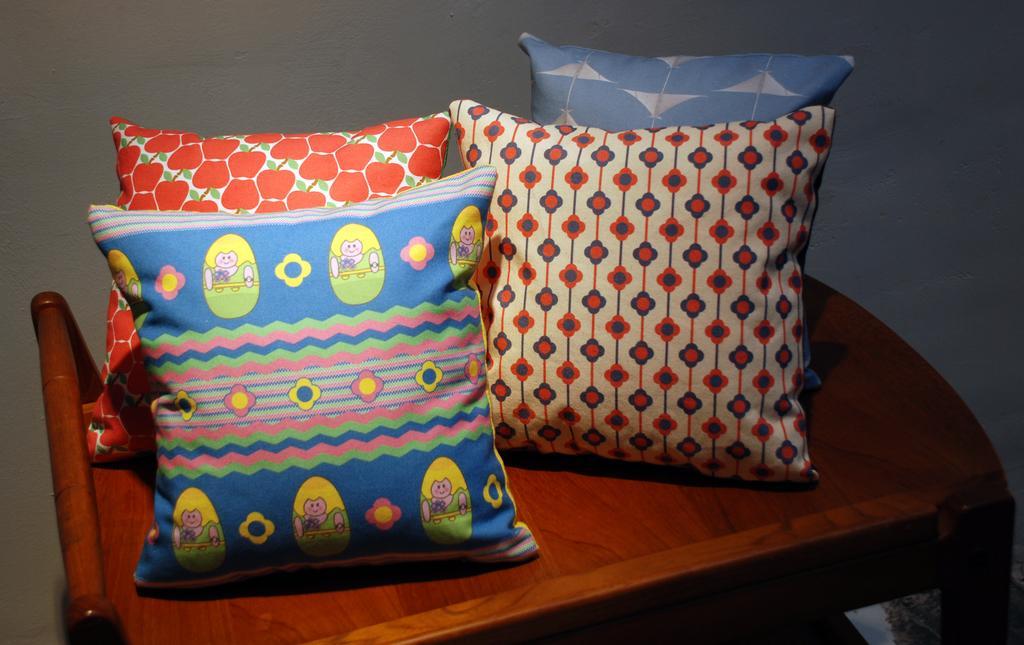In one or two sentences, can you explain what this image depicts? In this image there is a table truncated towards the bottom of the image, there are four pillows on the table, in the background of the image there is a wall. 